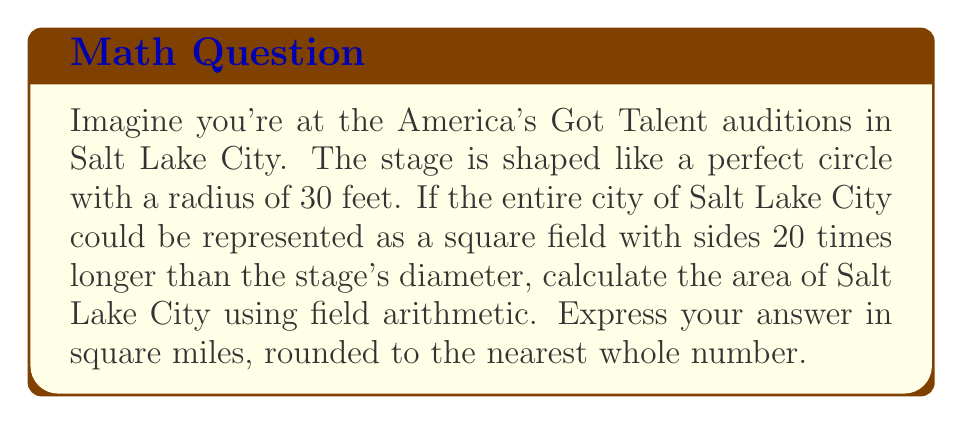Could you help me with this problem? Let's approach this step-by-step using field arithmetic:

1) First, we need to find the diameter of the stage:
   $$ d = 2r = 2 \cdot 30 = 60 \text{ feet} $$

2) Now, we can calculate the side length of the square representing Salt Lake City:
   $$ s = 20d = 20 \cdot 60 = 1200 \text{ feet} $$

3) The area of Salt Lake City in square feet would be:
   $$ A = s^2 = 1200^2 = 1,440,000 \text{ sq feet} $$

4) To convert this to square miles, we need to divide by the number of square feet in a square mile:
   $$ 1 \text{ sq mile} = 5280 \text{ feet} \times 5280 \text{ feet} = 27,878,400 \text{ sq feet} $$

5) Using field arithmetic, we can divide our area by this conversion factor:
   $$ A_{\text{miles}} = \frac{1,440,000}{27,878,400} \approx 0.0516 \text{ sq miles} $$

6) Rounding to the nearest whole number:
   $$ A_{\text{miles}} \approx 0 \text{ sq miles} $$

Note: This result is much smaller than the actual area of Salt Lake City due to the scale of our hypothetical scenario.
Answer: 0 sq miles 